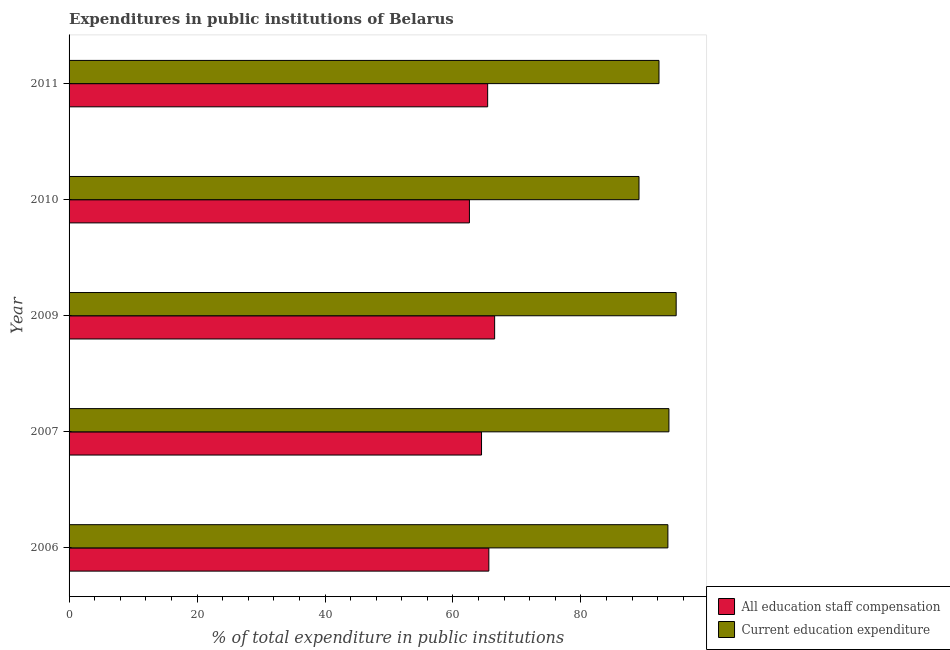How many groups of bars are there?
Your response must be concise. 5. Are the number of bars per tick equal to the number of legend labels?
Offer a terse response. Yes. Are the number of bars on each tick of the Y-axis equal?
Your answer should be very brief. Yes. How many bars are there on the 2nd tick from the bottom?
Offer a very short reply. 2. What is the expenditure in staff compensation in 2007?
Keep it short and to the point. 64.46. Across all years, what is the maximum expenditure in education?
Provide a short and direct response. 94.88. Across all years, what is the minimum expenditure in education?
Offer a very short reply. 89.07. In which year was the expenditure in staff compensation minimum?
Your response must be concise. 2010. What is the total expenditure in education in the graph?
Provide a succinct answer. 463.48. What is the difference between the expenditure in staff compensation in 2006 and that in 2010?
Your answer should be compact. 3.04. What is the difference between the expenditure in staff compensation in 2010 and the expenditure in education in 2006?
Give a very brief answer. -31.02. What is the average expenditure in education per year?
Ensure brevity in your answer.  92.7. In the year 2010, what is the difference between the expenditure in education and expenditure in staff compensation?
Your answer should be very brief. 26.5. In how many years, is the expenditure in education greater than 68 %?
Offer a very short reply. 5. What is the ratio of the expenditure in education in 2007 to that in 2010?
Offer a terse response. 1.05. Is the expenditure in education in 2006 less than that in 2007?
Make the answer very short. Yes. Is the difference between the expenditure in education in 2006 and 2007 greater than the difference between the expenditure in staff compensation in 2006 and 2007?
Your answer should be very brief. No. What is the difference between the highest and the second highest expenditure in education?
Offer a terse response. 1.13. What is the difference between the highest and the lowest expenditure in education?
Make the answer very short. 5.81. What does the 2nd bar from the top in 2011 represents?
Provide a short and direct response. All education staff compensation. What does the 1st bar from the bottom in 2011 represents?
Your response must be concise. All education staff compensation. How many bars are there?
Ensure brevity in your answer.  10. Are all the bars in the graph horizontal?
Your answer should be compact. Yes. How many years are there in the graph?
Your answer should be compact. 5. Are the values on the major ticks of X-axis written in scientific E-notation?
Your response must be concise. No. Where does the legend appear in the graph?
Make the answer very short. Bottom right. How many legend labels are there?
Your answer should be very brief. 2. How are the legend labels stacked?
Your response must be concise. Vertical. What is the title of the graph?
Your answer should be compact. Expenditures in public institutions of Belarus. Does "Merchandise exports" appear as one of the legend labels in the graph?
Provide a short and direct response. No. What is the label or title of the X-axis?
Your answer should be very brief. % of total expenditure in public institutions. What is the label or title of the Y-axis?
Your answer should be very brief. Year. What is the % of total expenditure in public institutions in All education staff compensation in 2006?
Your answer should be very brief. 65.6. What is the % of total expenditure in public institutions of Current education expenditure in 2006?
Offer a terse response. 93.59. What is the % of total expenditure in public institutions of All education staff compensation in 2007?
Offer a very short reply. 64.46. What is the % of total expenditure in public institutions of Current education expenditure in 2007?
Give a very brief answer. 93.75. What is the % of total expenditure in public institutions of All education staff compensation in 2009?
Keep it short and to the point. 66.51. What is the % of total expenditure in public institutions of Current education expenditure in 2009?
Ensure brevity in your answer.  94.88. What is the % of total expenditure in public institutions of All education staff compensation in 2010?
Your answer should be very brief. 62.57. What is the % of total expenditure in public institutions of Current education expenditure in 2010?
Give a very brief answer. 89.07. What is the % of total expenditure in public institutions in All education staff compensation in 2011?
Give a very brief answer. 65.42. What is the % of total expenditure in public institutions of Current education expenditure in 2011?
Give a very brief answer. 92.2. Across all years, what is the maximum % of total expenditure in public institutions of All education staff compensation?
Make the answer very short. 66.51. Across all years, what is the maximum % of total expenditure in public institutions in Current education expenditure?
Provide a short and direct response. 94.88. Across all years, what is the minimum % of total expenditure in public institutions of All education staff compensation?
Ensure brevity in your answer.  62.57. Across all years, what is the minimum % of total expenditure in public institutions in Current education expenditure?
Your answer should be compact. 89.07. What is the total % of total expenditure in public institutions in All education staff compensation in the graph?
Give a very brief answer. 324.56. What is the total % of total expenditure in public institutions of Current education expenditure in the graph?
Give a very brief answer. 463.48. What is the difference between the % of total expenditure in public institutions of All education staff compensation in 2006 and that in 2007?
Offer a very short reply. 1.14. What is the difference between the % of total expenditure in public institutions in Current education expenditure in 2006 and that in 2007?
Ensure brevity in your answer.  -0.16. What is the difference between the % of total expenditure in public institutions in All education staff compensation in 2006 and that in 2009?
Provide a succinct answer. -0.91. What is the difference between the % of total expenditure in public institutions in Current education expenditure in 2006 and that in 2009?
Keep it short and to the point. -1.29. What is the difference between the % of total expenditure in public institutions in All education staff compensation in 2006 and that in 2010?
Give a very brief answer. 3.04. What is the difference between the % of total expenditure in public institutions in Current education expenditure in 2006 and that in 2010?
Offer a very short reply. 4.52. What is the difference between the % of total expenditure in public institutions of All education staff compensation in 2006 and that in 2011?
Your answer should be very brief. 0.19. What is the difference between the % of total expenditure in public institutions in Current education expenditure in 2006 and that in 2011?
Offer a very short reply. 1.39. What is the difference between the % of total expenditure in public institutions in All education staff compensation in 2007 and that in 2009?
Your response must be concise. -2.05. What is the difference between the % of total expenditure in public institutions of Current education expenditure in 2007 and that in 2009?
Ensure brevity in your answer.  -1.13. What is the difference between the % of total expenditure in public institutions of All education staff compensation in 2007 and that in 2010?
Offer a terse response. 1.89. What is the difference between the % of total expenditure in public institutions in Current education expenditure in 2007 and that in 2010?
Offer a very short reply. 4.68. What is the difference between the % of total expenditure in public institutions in All education staff compensation in 2007 and that in 2011?
Offer a very short reply. -0.96. What is the difference between the % of total expenditure in public institutions in Current education expenditure in 2007 and that in 2011?
Ensure brevity in your answer.  1.55. What is the difference between the % of total expenditure in public institutions of All education staff compensation in 2009 and that in 2010?
Your response must be concise. 3.94. What is the difference between the % of total expenditure in public institutions of Current education expenditure in 2009 and that in 2010?
Offer a very short reply. 5.81. What is the difference between the % of total expenditure in public institutions of All education staff compensation in 2009 and that in 2011?
Your response must be concise. 1.09. What is the difference between the % of total expenditure in public institutions in Current education expenditure in 2009 and that in 2011?
Make the answer very short. 2.68. What is the difference between the % of total expenditure in public institutions in All education staff compensation in 2010 and that in 2011?
Offer a very short reply. -2.85. What is the difference between the % of total expenditure in public institutions in Current education expenditure in 2010 and that in 2011?
Make the answer very short. -3.12. What is the difference between the % of total expenditure in public institutions of All education staff compensation in 2006 and the % of total expenditure in public institutions of Current education expenditure in 2007?
Ensure brevity in your answer.  -28.14. What is the difference between the % of total expenditure in public institutions in All education staff compensation in 2006 and the % of total expenditure in public institutions in Current education expenditure in 2009?
Make the answer very short. -29.28. What is the difference between the % of total expenditure in public institutions of All education staff compensation in 2006 and the % of total expenditure in public institutions of Current education expenditure in 2010?
Give a very brief answer. -23.47. What is the difference between the % of total expenditure in public institutions in All education staff compensation in 2006 and the % of total expenditure in public institutions in Current education expenditure in 2011?
Your answer should be very brief. -26.59. What is the difference between the % of total expenditure in public institutions in All education staff compensation in 2007 and the % of total expenditure in public institutions in Current education expenditure in 2009?
Your answer should be compact. -30.42. What is the difference between the % of total expenditure in public institutions of All education staff compensation in 2007 and the % of total expenditure in public institutions of Current education expenditure in 2010?
Offer a very short reply. -24.61. What is the difference between the % of total expenditure in public institutions of All education staff compensation in 2007 and the % of total expenditure in public institutions of Current education expenditure in 2011?
Make the answer very short. -27.73. What is the difference between the % of total expenditure in public institutions of All education staff compensation in 2009 and the % of total expenditure in public institutions of Current education expenditure in 2010?
Provide a succinct answer. -22.56. What is the difference between the % of total expenditure in public institutions of All education staff compensation in 2009 and the % of total expenditure in public institutions of Current education expenditure in 2011?
Offer a very short reply. -25.68. What is the difference between the % of total expenditure in public institutions of All education staff compensation in 2010 and the % of total expenditure in public institutions of Current education expenditure in 2011?
Make the answer very short. -29.63. What is the average % of total expenditure in public institutions in All education staff compensation per year?
Your response must be concise. 64.91. What is the average % of total expenditure in public institutions in Current education expenditure per year?
Provide a succinct answer. 92.7. In the year 2006, what is the difference between the % of total expenditure in public institutions in All education staff compensation and % of total expenditure in public institutions in Current education expenditure?
Make the answer very short. -27.98. In the year 2007, what is the difference between the % of total expenditure in public institutions in All education staff compensation and % of total expenditure in public institutions in Current education expenditure?
Give a very brief answer. -29.29. In the year 2009, what is the difference between the % of total expenditure in public institutions of All education staff compensation and % of total expenditure in public institutions of Current education expenditure?
Keep it short and to the point. -28.37. In the year 2010, what is the difference between the % of total expenditure in public institutions in All education staff compensation and % of total expenditure in public institutions in Current education expenditure?
Ensure brevity in your answer.  -26.5. In the year 2011, what is the difference between the % of total expenditure in public institutions in All education staff compensation and % of total expenditure in public institutions in Current education expenditure?
Keep it short and to the point. -26.78. What is the ratio of the % of total expenditure in public institutions of All education staff compensation in 2006 to that in 2007?
Ensure brevity in your answer.  1.02. What is the ratio of the % of total expenditure in public institutions of Current education expenditure in 2006 to that in 2007?
Give a very brief answer. 1. What is the ratio of the % of total expenditure in public institutions in All education staff compensation in 2006 to that in 2009?
Your response must be concise. 0.99. What is the ratio of the % of total expenditure in public institutions of Current education expenditure in 2006 to that in 2009?
Offer a terse response. 0.99. What is the ratio of the % of total expenditure in public institutions in All education staff compensation in 2006 to that in 2010?
Offer a terse response. 1.05. What is the ratio of the % of total expenditure in public institutions of Current education expenditure in 2006 to that in 2010?
Your answer should be compact. 1.05. What is the ratio of the % of total expenditure in public institutions in All education staff compensation in 2006 to that in 2011?
Your answer should be very brief. 1. What is the ratio of the % of total expenditure in public institutions of Current education expenditure in 2006 to that in 2011?
Ensure brevity in your answer.  1.02. What is the ratio of the % of total expenditure in public institutions in All education staff compensation in 2007 to that in 2009?
Ensure brevity in your answer.  0.97. What is the ratio of the % of total expenditure in public institutions in Current education expenditure in 2007 to that in 2009?
Your answer should be very brief. 0.99. What is the ratio of the % of total expenditure in public institutions in All education staff compensation in 2007 to that in 2010?
Your response must be concise. 1.03. What is the ratio of the % of total expenditure in public institutions of Current education expenditure in 2007 to that in 2010?
Give a very brief answer. 1.05. What is the ratio of the % of total expenditure in public institutions of All education staff compensation in 2007 to that in 2011?
Provide a short and direct response. 0.99. What is the ratio of the % of total expenditure in public institutions in Current education expenditure in 2007 to that in 2011?
Provide a succinct answer. 1.02. What is the ratio of the % of total expenditure in public institutions of All education staff compensation in 2009 to that in 2010?
Give a very brief answer. 1.06. What is the ratio of the % of total expenditure in public institutions in Current education expenditure in 2009 to that in 2010?
Make the answer very short. 1.07. What is the ratio of the % of total expenditure in public institutions of All education staff compensation in 2009 to that in 2011?
Keep it short and to the point. 1.02. What is the ratio of the % of total expenditure in public institutions of Current education expenditure in 2009 to that in 2011?
Offer a very short reply. 1.03. What is the ratio of the % of total expenditure in public institutions of All education staff compensation in 2010 to that in 2011?
Provide a succinct answer. 0.96. What is the ratio of the % of total expenditure in public institutions of Current education expenditure in 2010 to that in 2011?
Make the answer very short. 0.97. What is the difference between the highest and the second highest % of total expenditure in public institutions of All education staff compensation?
Keep it short and to the point. 0.91. What is the difference between the highest and the second highest % of total expenditure in public institutions of Current education expenditure?
Your response must be concise. 1.13. What is the difference between the highest and the lowest % of total expenditure in public institutions in All education staff compensation?
Your response must be concise. 3.94. What is the difference between the highest and the lowest % of total expenditure in public institutions in Current education expenditure?
Offer a terse response. 5.81. 